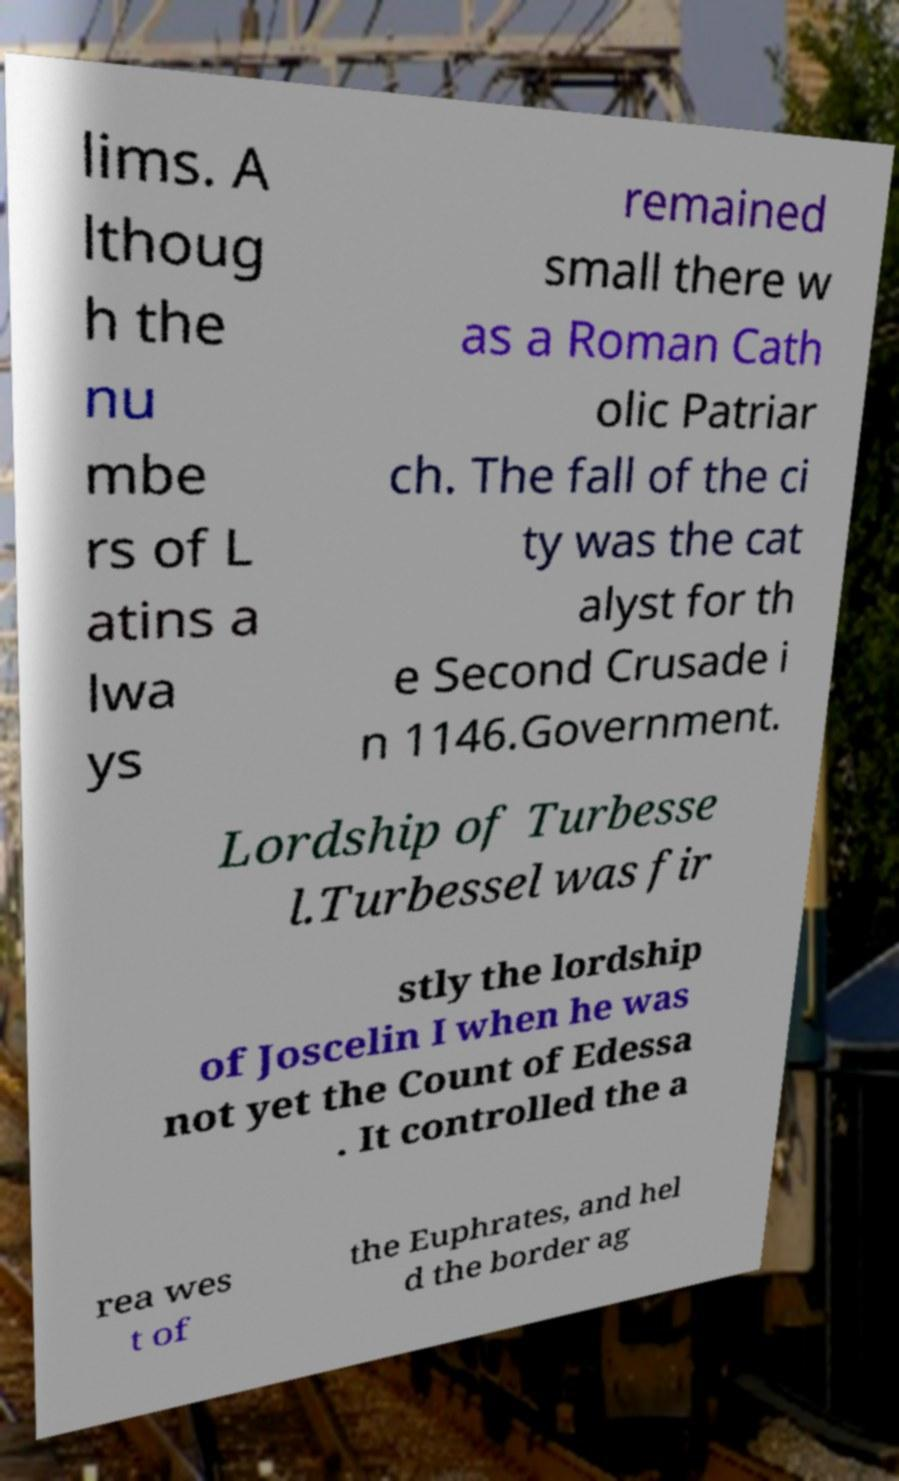Please identify and transcribe the text found in this image. lims. A lthoug h the nu mbe rs of L atins a lwa ys remained small there w as a Roman Cath olic Patriar ch. The fall of the ci ty was the cat alyst for th e Second Crusade i n 1146.Government. Lordship of Turbesse l.Turbessel was fir stly the lordship of Joscelin I when he was not yet the Count of Edessa . It controlled the a rea wes t of the Euphrates, and hel d the border ag 